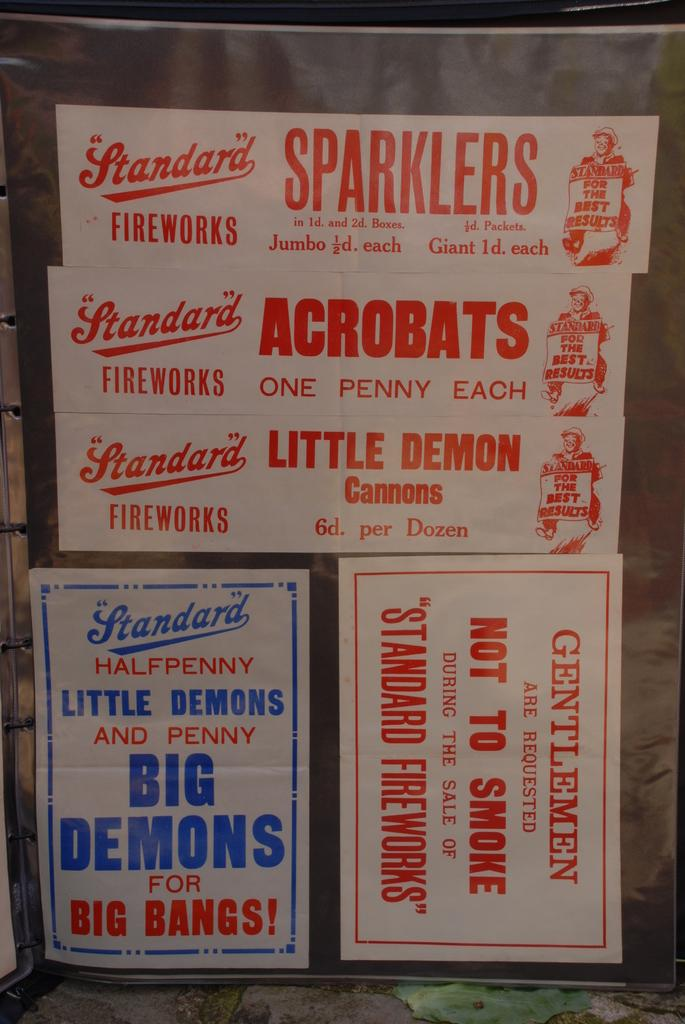<image>
Provide a brief description of the given image. A bunch of different fireworks stickers including a warning not to smoke. 